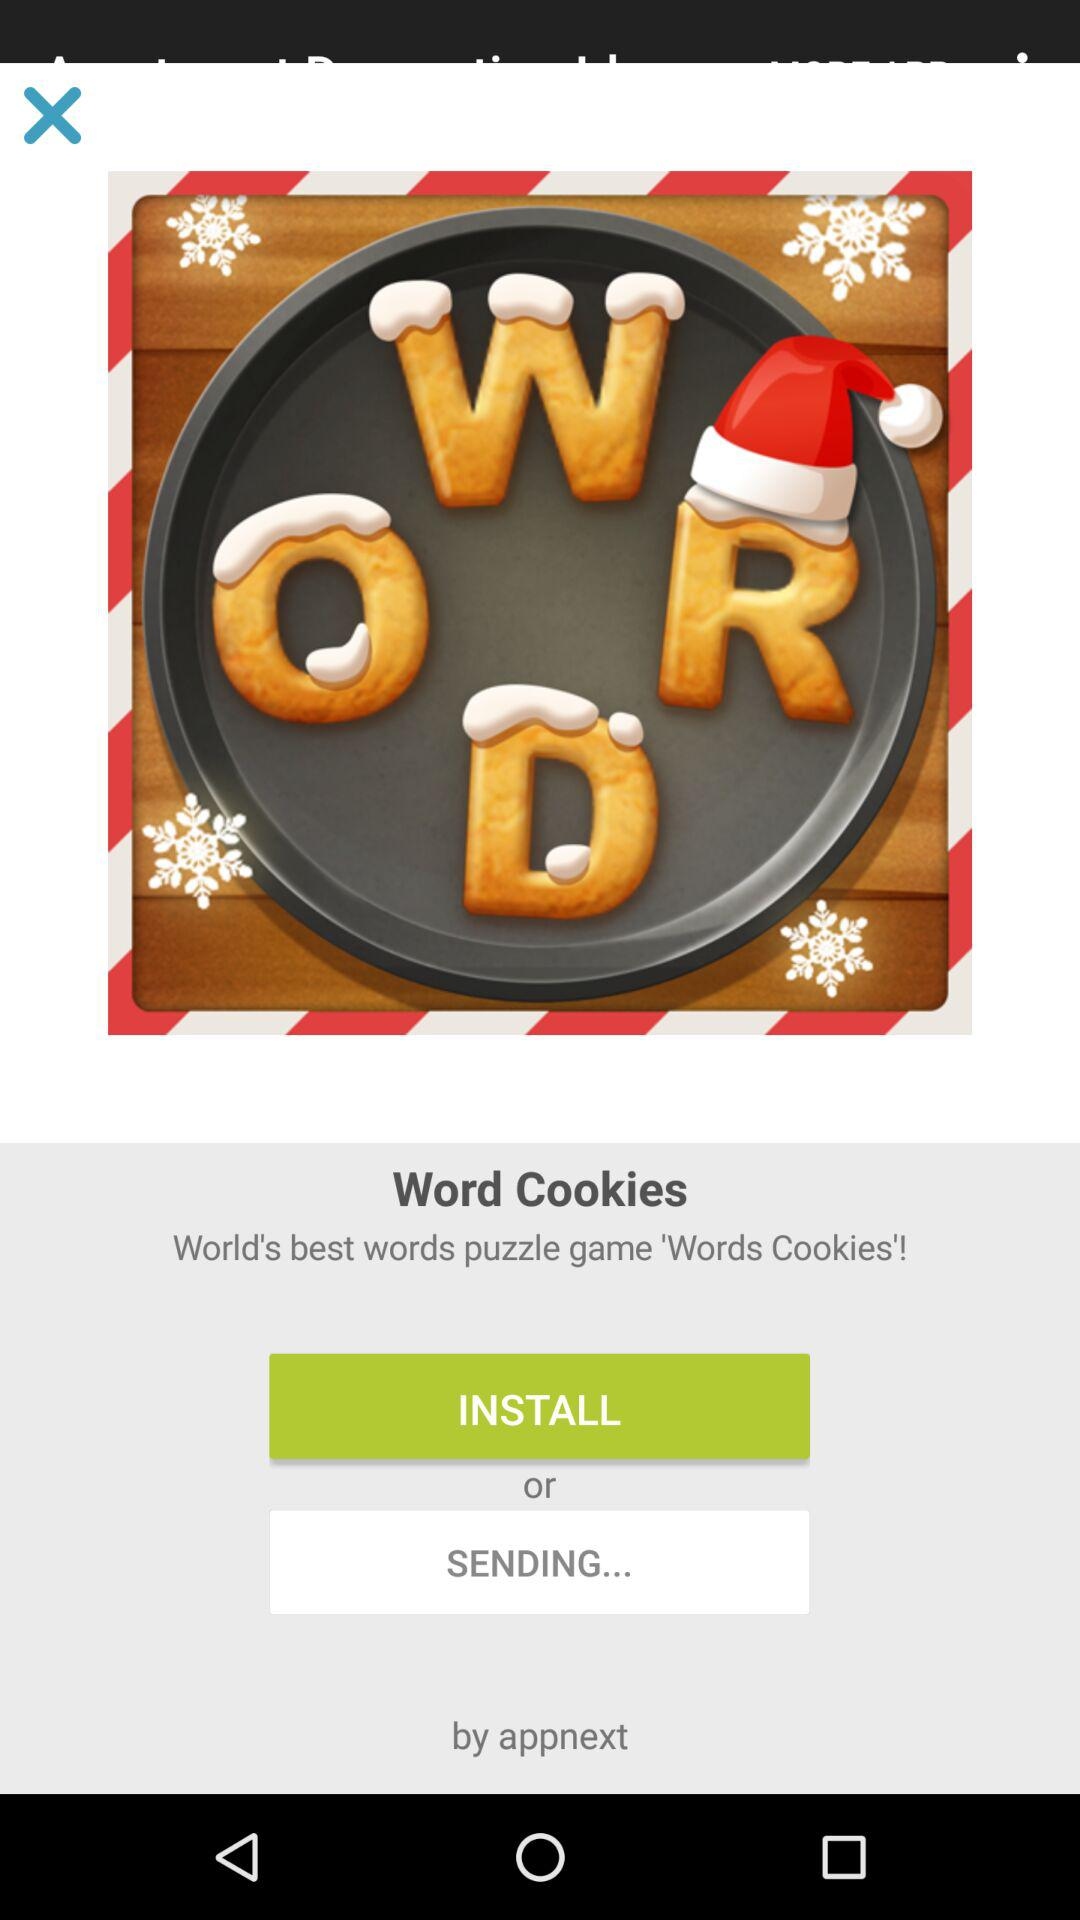What is the name of the application? The name of the application is "Word Cookies". 